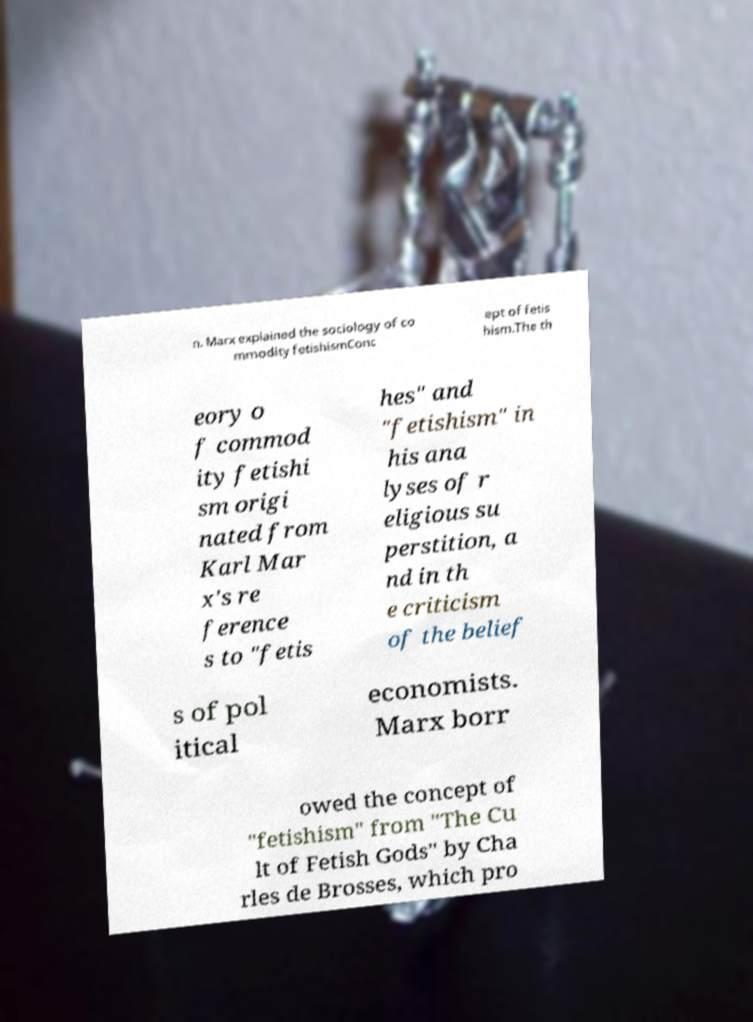Can you accurately transcribe the text from the provided image for me? n. Marx explained the sociology of co mmodity fetishismConc ept of fetis hism.The th eory o f commod ity fetishi sm origi nated from Karl Mar x's re ference s to "fetis hes" and "fetishism" in his ana lyses of r eligious su perstition, a nd in th e criticism of the belief s of pol itical economists. Marx borr owed the concept of "fetishism" from "The Cu lt of Fetish Gods" by Cha rles de Brosses, which pro 